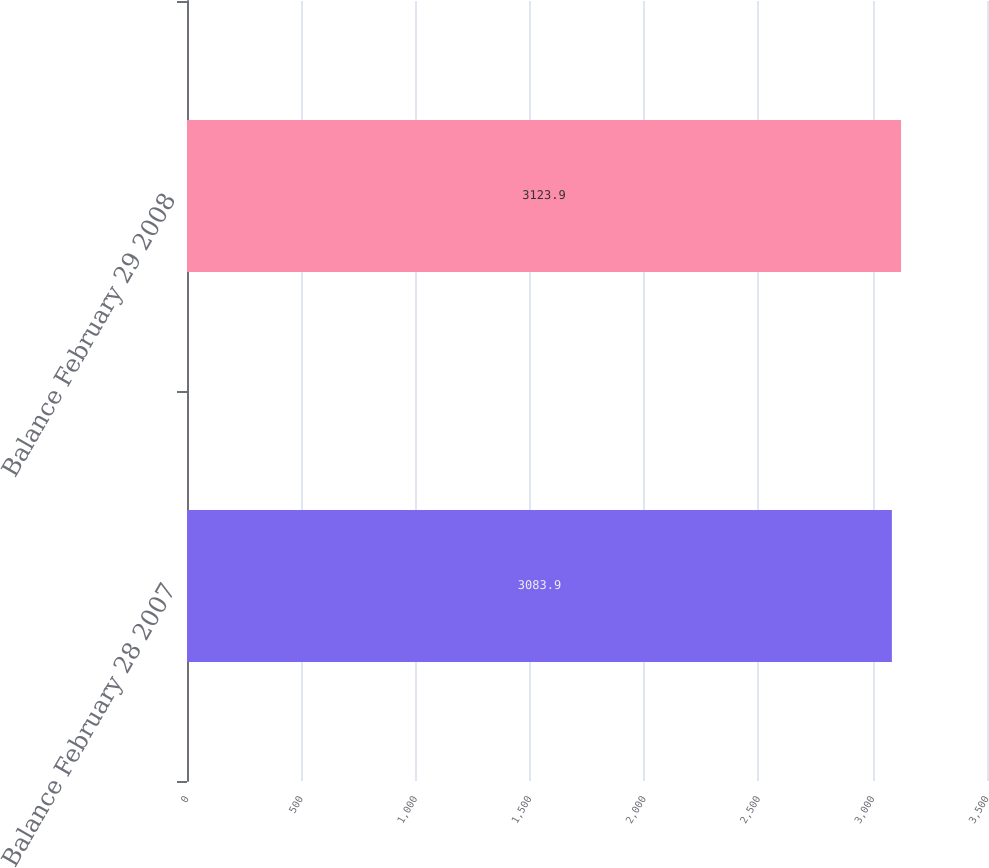Convert chart. <chart><loc_0><loc_0><loc_500><loc_500><bar_chart><fcel>Balance February 28 2007<fcel>Balance February 29 2008<nl><fcel>3083.9<fcel>3123.9<nl></chart> 